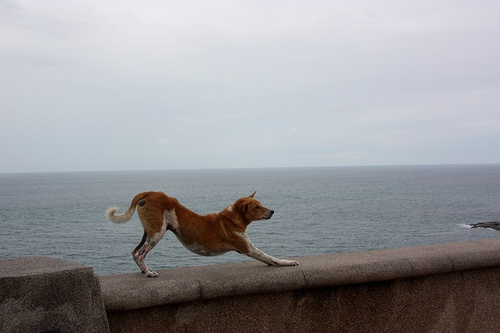Describe the objects in this image and their specific colors. I can see a dog in lightgray, black, maroon, and gray tones in this image. 